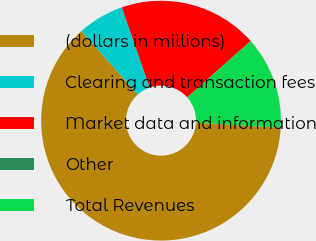<chart> <loc_0><loc_0><loc_500><loc_500><pie_chart><fcel>(dollars in millions)<fcel>Clearing and transaction fees<fcel>Market data and information<fcel>Other<fcel>Total Revenues<nl><fcel>62.5%<fcel>6.25%<fcel>18.75%<fcel>0.0%<fcel>12.5%<nl></chart> 